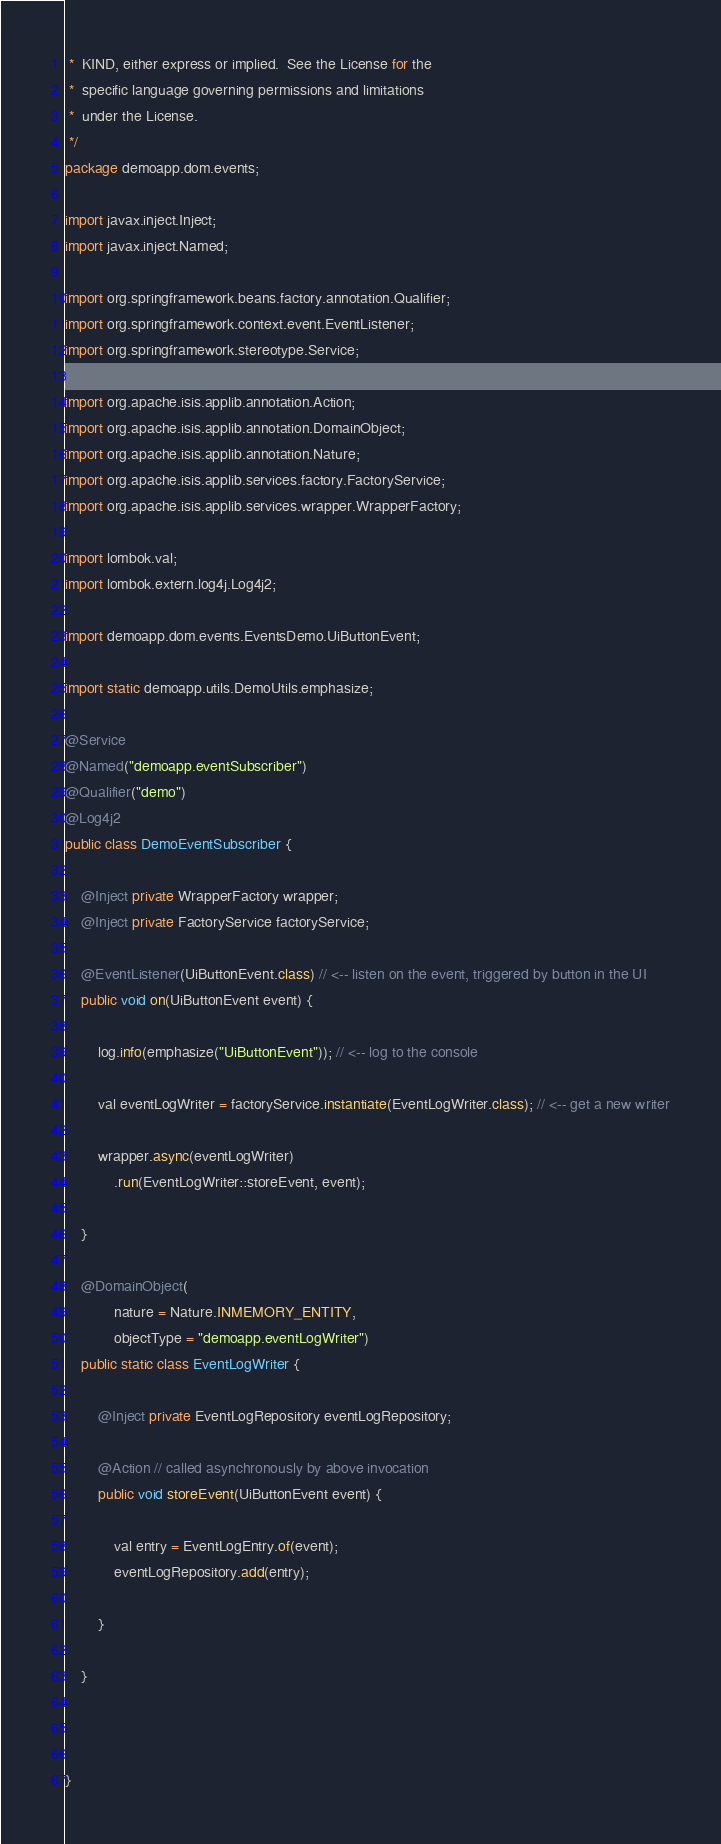Convert code to text. <code><loc_0><loc_0><loc_500><loc_500><_Java_> *  KIND, either express or implied.  See the License for the
 *  specific language governing permissions and limitations
 *  under the License.
 */
package demoapp.dom.events;

import javax.inject.Inject;
import javax.inject.Named;

import org.springframework.beans.factory.annotation.Qualifier;
import org.springframework.context.event.EventListener;
import org.springframework.stereotype.Service;

import org.apache.isis.applib.annotation.Action;
import org.apache.isis.applib.annotation.DomainObject;
import org.apache.isis.applib.annotation.Nature;
import org.apache.isis.applib.services.factory.FactoryService;
import org.apache.isis.applib.services.wrapper.WrapperFactory;

import lombok.val;
import lombok.extern.log4j.Log4j2;

import demoapp.dom.events.EventsDemo.UiButtonEvent;

import static demoapp.utils.DemoUtils.emphasize;

@Service
@Named("demoapp.eventSubscriber")
@Qualifier("demo")
@Log4j2
public class DemoEventSubscriber {

    @Inject private WrapperFactory wrapper;
    @Inject private FactoryService factoryService;
    
    @EventListener(UiButtonEvent.class) // <-- listen on the event, triggered by button in the UI 
    public void on(UiButtonEvent event) {

        log.info(emphasize("UiButtonEvent")); // <-- log to the console
        
        val eventLogWriter = factoryService.instantiate(EventLogWriter.class); // <-- get a new writer
        
        wrapper.async(eventLogWriter)
            .run(EventLogWriter::storeEvent, event);

    }

    @DomainObject(
            nature = Nature.INMEMORY_ENTITY, 
            objectType = "demoapp.eventLogWriter")
    public static class EventLogWriter {

        @Inject private EventLogRepository eventLogRepository;
        
        @Action // called asynchronously by above invocation 
        public void storeEvent(UiButtonEvent event) {
            
            val entry = EventLogEntry.of(event);
            eventLogRepository.add(entry);
            
        }
        
    }
    
    

}
</code> 